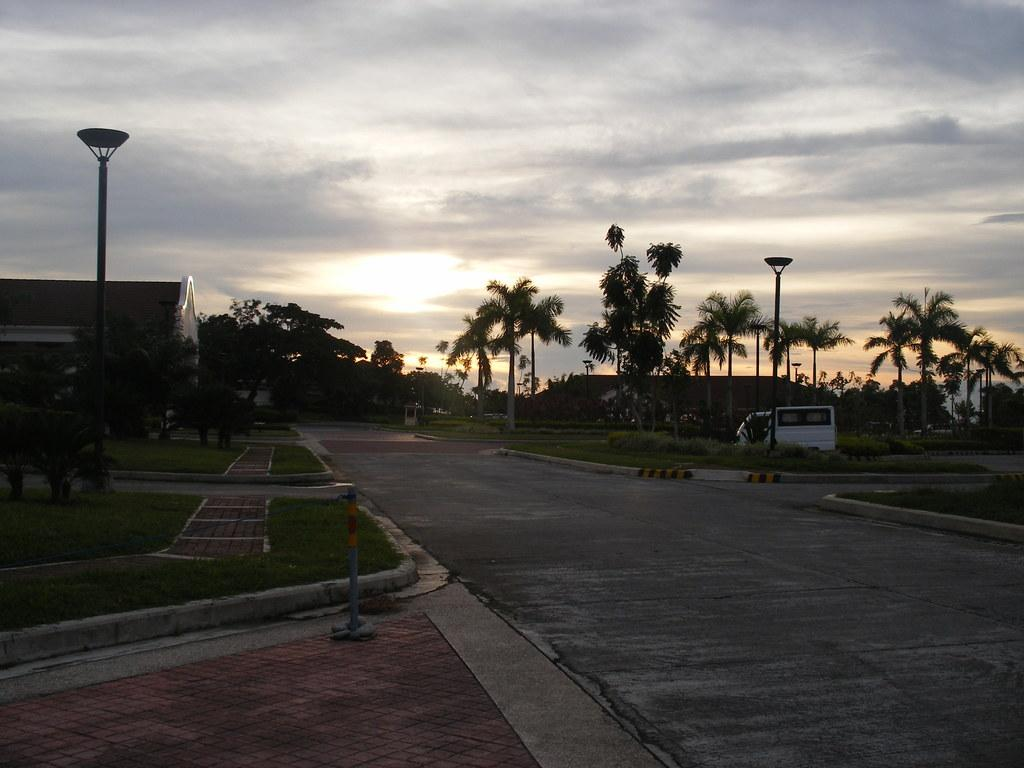Where was the image taken? The image was clicked outside. What can be seen in the middle of the image? There are trees and a vehicle in the middle of the image. What is the color of the vehicle? The vehicle is white in color. What is located on the left side of the image? There is a building on the left side of the image. What is visible at the top of the image? The sky is visible at the top of the image. What type of pen is being used to write on the vehicle in the image? There is no pen or writing visible on the vehicle in the image. How many cattle can be seen grazing in the background of the image? There are no cattle present in the image. 